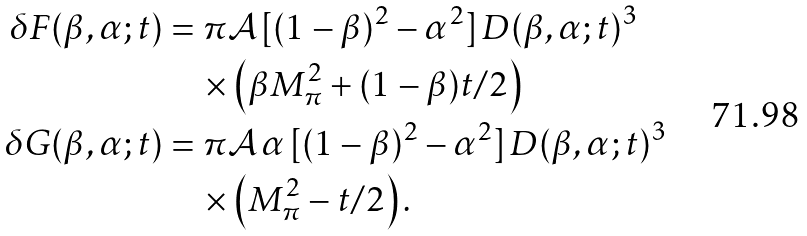<formula> <loc_0><loc_0><loc_500><loc_500>\delta F ( \beta , \alpha ; t ) & = \pi \mathcal { A } \, [ ( 1 - \beta ) ^ { 2 } - \alpha ^ { 2 } ] \, D ( \beta , \alpha ; t ) ^ { 3 } \\ & \quad \times \left ( \beta M _ { \pi } ^ { 2 } + ( 1 - \beta ) t / 2 \right ) \\ \delta G ( \beta , \alpha ; t ) & = \pi \mathcal { A } \, \alpha \, [ ( 1 - \beta ) ^ { 2 } - \alpha ^ { 2 } ] \, D ( \beta , \alpha ; t ) ^ { 3 } \\ & \quad \times \left ( M ^ { 2 } _ { \pi } - t / 2 \right ) .</formula> 